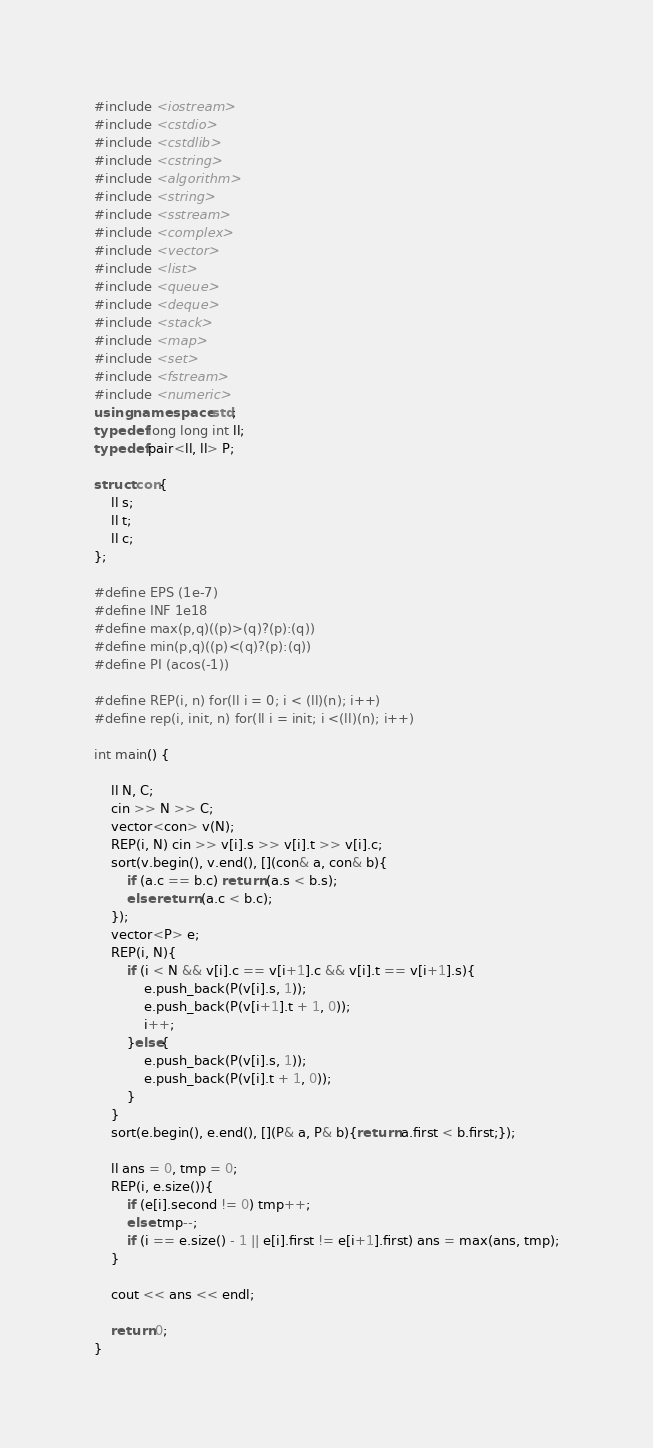Convert code to text. <code><loc_0><loc_0><loc_500><loc_500><_C++_>
#include <iostream>
#include <cstdio>
#include <cstdlib>
#include <cstring>
#include <algorithm>
#include <string>
#include <sstream>
#include <complex>
#include <vector>
#include <list>
#include <queue>
#include <deque>
#include <stack>
#include <map>
#include <set>
#include <fstream>
#include <numeric>
using namespace std;
typedef long long int ll;
typedef pair<ll, ll> P;

struct con{
    ll s;
    ll t;
    ll c;
};

#define EPS (1e-7)
#define INF 1e18
#define max(p,q)((p)>(q)?(p):(q))
#define min(p,q)((p)<(q)?(p):(q))
#define PI (acos(-1))

#define REP(i, n) for(ll i = 0; i < (ll)(n); i++)
#define rep(i, init, n) for(ll i = init; i <(ll)(n); i++)

int main() {

    ll N, C;
    cin >> N >> C;
    vector<con> v(N);
    REP(i, N) cin >> v[i].s >> v[i].t >> v[i].c;
    sort(v.begin(), v.end(), [](con& a, con& b){
        if (a.c == b.c) return (a.s < b.s);
        else return (a.c < b.c);
    });
    vector<P> e;
    REP(i, N){
        if (i < N && v[i].c == v[i+1].c && v[i].t == v[i+1].s){
            e.push_back(P(v[i].s, 1));
            e.push_back(P(v[i+1].t + 1, 0));
            i++;
        }else{
            e.push_back(P(v[i].s, 1));
            e.push_back(P(v[i].t + 1, 0));
        }
    }
    sort(e.begin(), e.end(), [](P& a, P& b){return a.first < b.first;});

    ll ans = 0, tmp = 0;
    REP(i, e.size()){
        if (e[i].second != 0) tmp++;
        else tmp--;
        if (i == e.size() - 1 || e[i].first != e[i+1].first) ans = max(ans, tmp);
    }

    cout << ans << endl;

    return 0;
}

</code> 